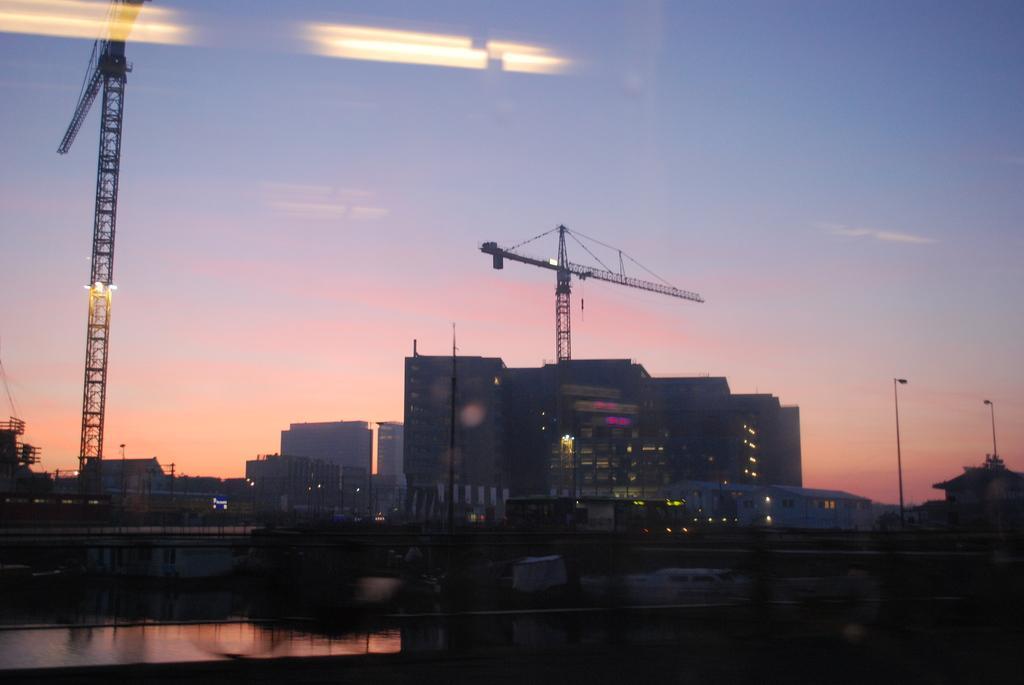In one or two sentences, can you explain what this image depicts? Behind the road there are few buildings, some of them are under construction beside the building there are very huge cranes and in the background there is a sky 